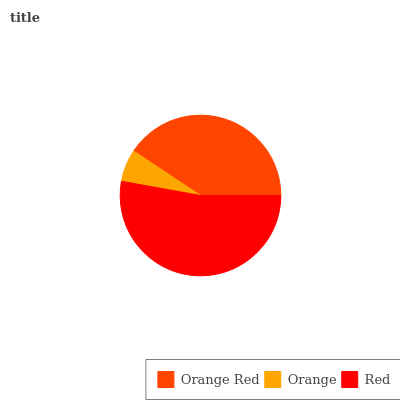Is Orange the minimum?
Answer yes or no. Yes. Is Red the maximum?
Answer yes or no. Yes. Is Red the minimum?
Answer yes or no. No. Is Orange the maximum?
Answer yes or no. No. Is Red greater than Orange?
Answer yes or no. Yes. Is Orange less than Red?
Answer yes or no. Yes. Is Orange greater than Red?
Answer yes or no. No. Is Red less than Orange?
Answer yes or no. No. Is Orange Red the high median?
Answer yes or no. Yes. Is Orange Red the low median?
Answer yes or no. Yes. Is Orange the high median?
Answer yes or no. No. Is Red the low median?
Answer yes or no. No. 